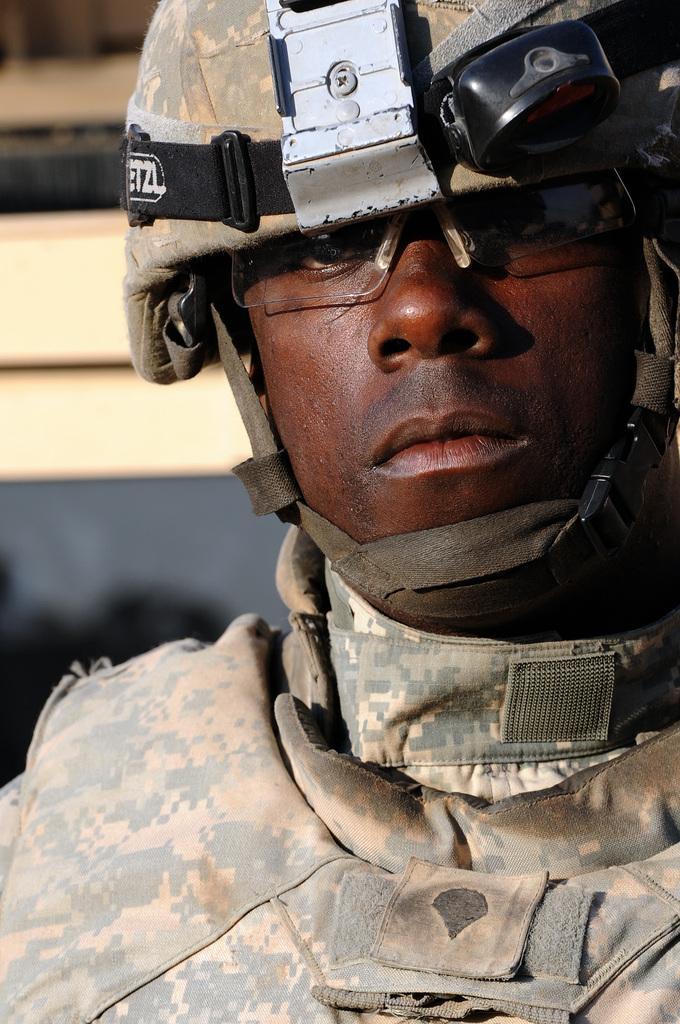In one or two sentences, can you explain what this image depicts? In the picture I can see a soldier. There is a helmet on his head and I can see the safety goggles on his eyes. 